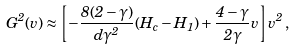Convert formula to latex. <formula><loc_0><loc_0><loc_500><loc_500>G ^ { 2 } ( v ) \approx \left [ - \frac { 8 ( 2 - \gamma ) } { { d } \gamma ^ { 2 } } ( H _ { c } - H _ { 1 } ) + \frac { 4 - \gamma } { 2 \gamma } v \right ] v ^ { 2 } \, ,</formula> 